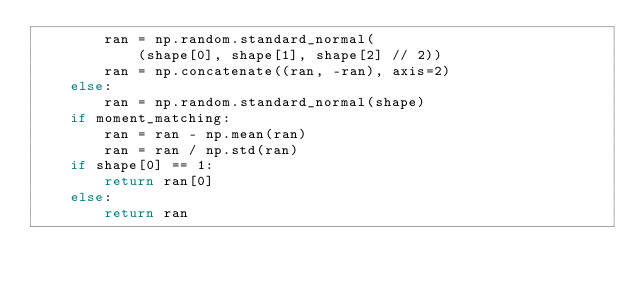Convert code to text. <code><loc_0><loc_0><loc_500><loc_500><_Python_>        ran = np.random.standard_normal(
            (shape[0], shape[1], shape[2] // 2))
        ran = np.concatenate((ran, -ran), axis=2)
    else:
        ran = np.random.standard_normal(shape)
    if moment_matching:
        ran = ran - np.mean(ran)
        ran = ran / np.std(ran)
    if shape[0] == 1:
        return ran[0]
    else:
        return ran</code> 